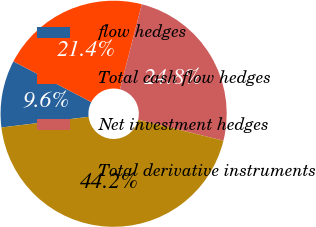Convert chart to OTSL. <chart><loc_0><loc_0><loc_500><loc_500><pie_chart><fcel>flow hedges<fcel>Total cash flow hedges<fcel>Net investment hedges<fcel>Total derivative instruments<nl><fcel>9.6%<fcel>21.35%<fcel>24.81%<fcel>44.24%<nl></chart> 